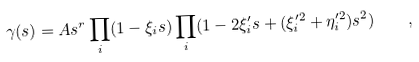Convert formula to latex. <formula><loc_0><loc_0><loc_500><loc_500>\gamma ( s ) = A s ^ { r } \prod _ { i } ( 1 - \xi _ { i } s ) \prod _ { i } ( 1 - 2 \xi _ { i } ^ { \prime } s + ( \xi _ { i } ^ { \prime 2 } + \eta _ { i } ^ { \prime 2 } ) s ^ { 2 } ) \quad ,</formula> 